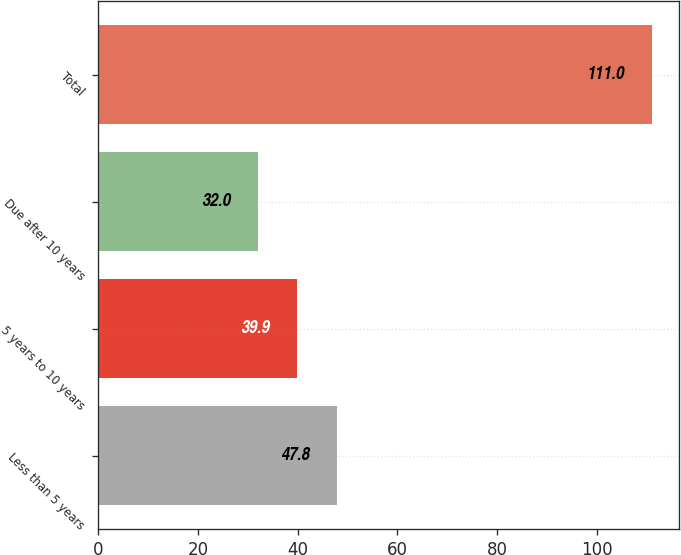Convert chart. <chart><loc_0><loc_0><loc_500><loc_500><bar_chart><fcel>Less than 5 years<fcel>5 years to 10 years<fcel>Due after 10 years<fcel>Total<nl><fcel>47.8<fcel>39.9<fcel>32<fcel>111<nl></chart> 